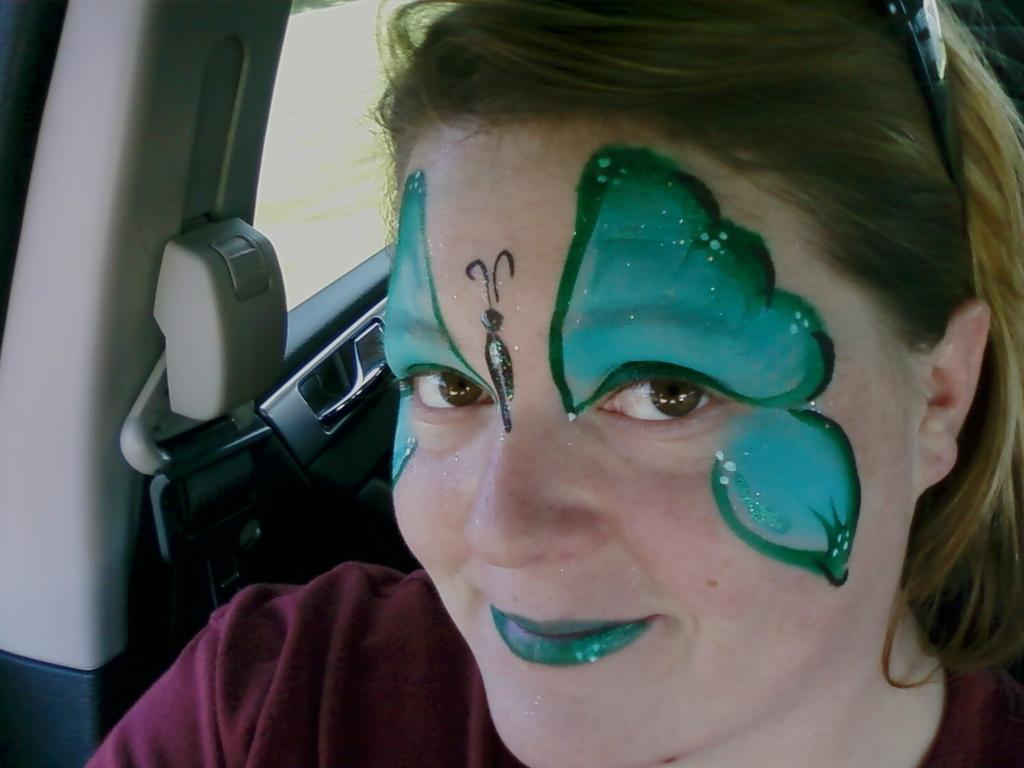Who is present in the image? There is a woman in the image. What is the woman doing in the image? The woman is sitting in a vehicle. Can you describe any unique features of the woman? The woman has a painting on her face. What safety feature is visible in the image? There is a seat belt beside her. What type of lumber can be seen stacked in the background of the image? There is no lumber present in the image; it features a woman sitting in a vehicle with a painting on her face. 